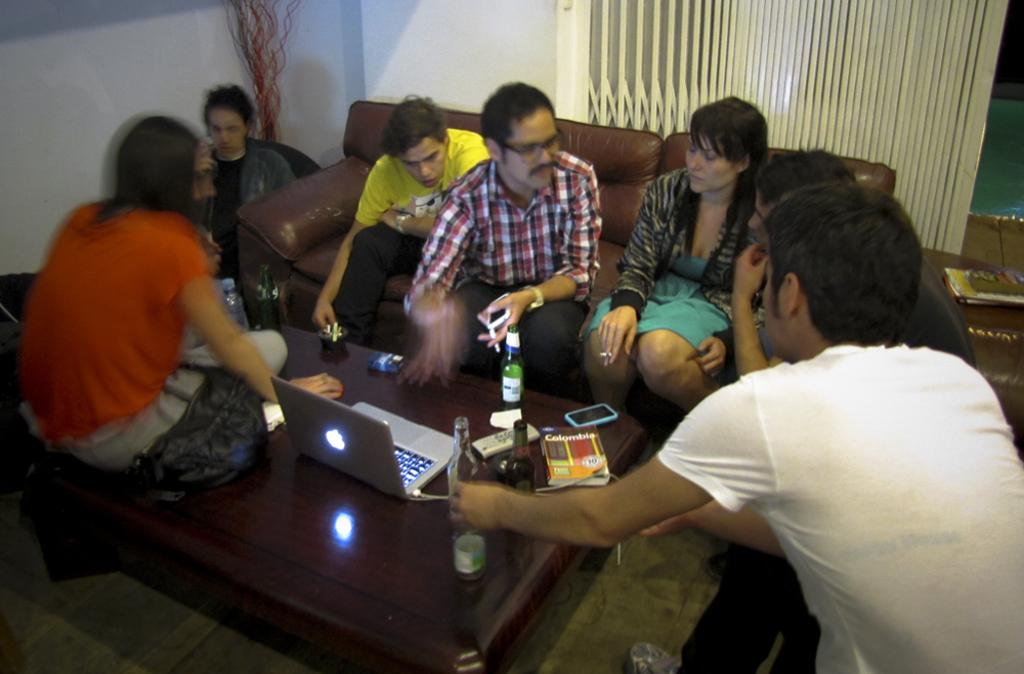What are the people in the image doing? There is a group of people sitting on a sofa in the image. What is in front of the sofa? There is a table in front of the sofa. What is the lady doing in the image? A lady is sitting on the table in the image. What electronic devices are on the table? There is a MacBook and a mobile phone on the table. What else can be seen on the table? There are drink bottles on the table. Can you tell me how many ducks are in the cave in the image? There is no cave or duck present in the image. Is there a church visible in the background of the image? There is no church visible in the image; it features a group of people sitting on a sofa with a table in front of it. 